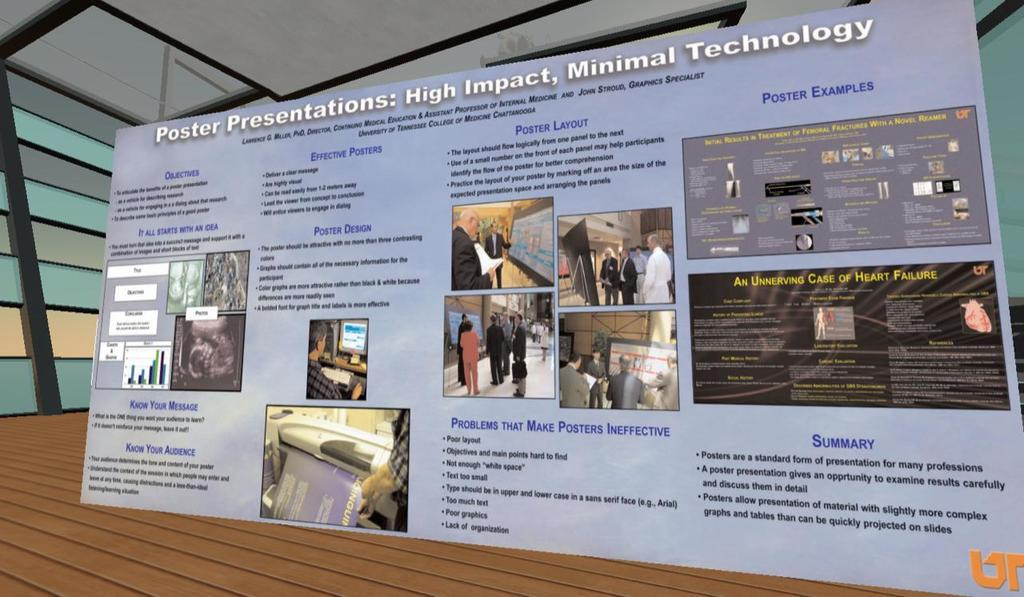<image>
Present a compact description of the photo's key features. A large poster that explains how to make Effective Posters and Problems The Make Posters Ineffective 